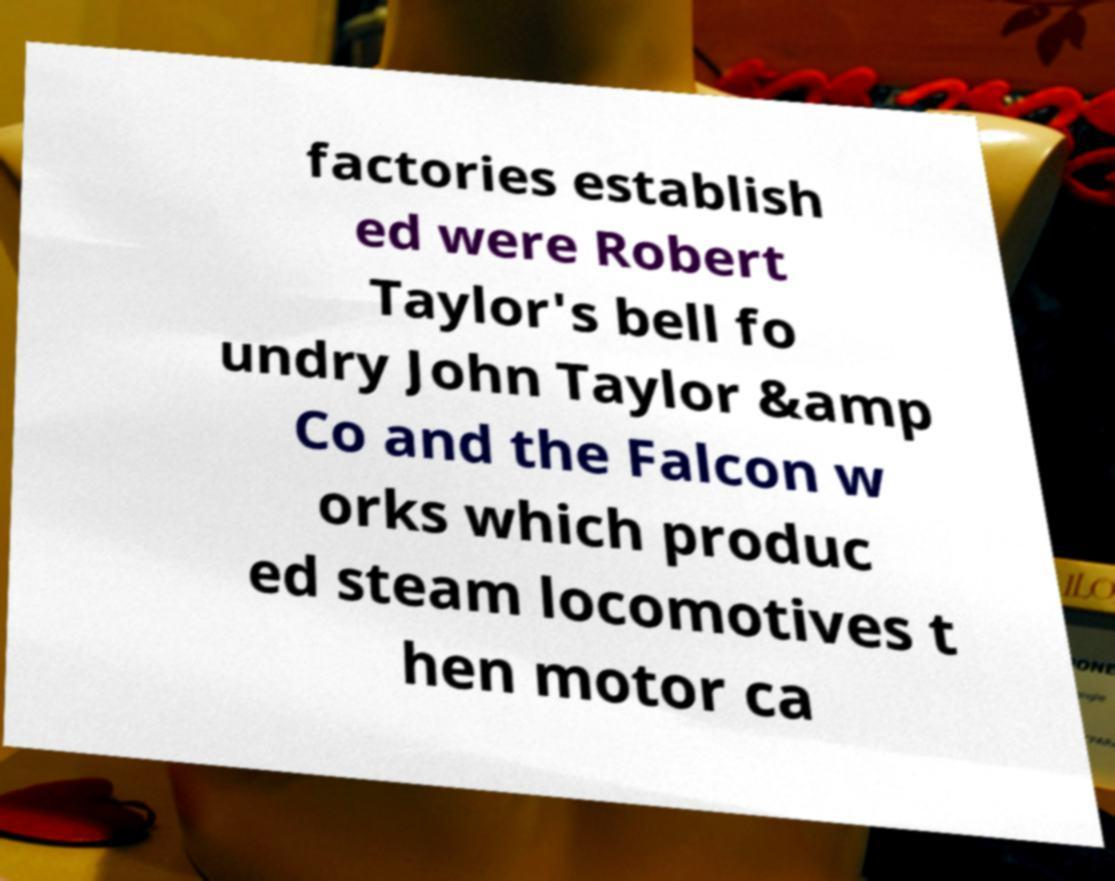For documentation purposes, I need the text within this image transcribed. Could you provide that? factories establish ed were Robert Taylor's bell fo undry John Taylor &amp Co and the Falcon w orks which produc ed steam locomotives t hen motor ca 